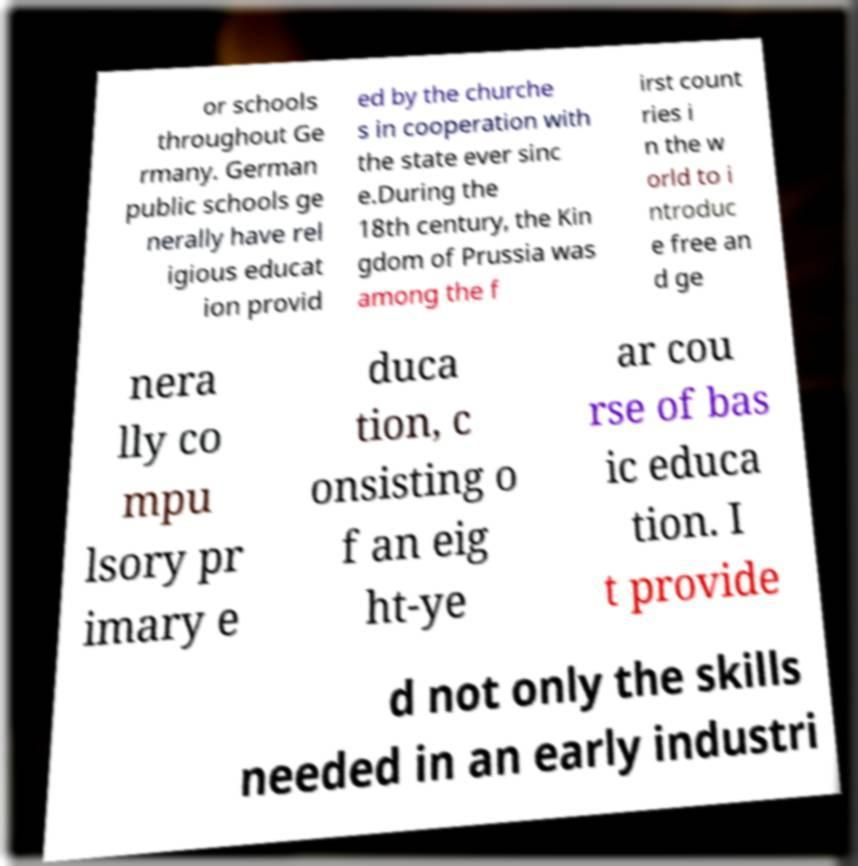Could you assist in decoding the text presented in this image and type it out clearly? or schools throughout Ge rmany. German public schools ge nerally have rel igious educat ion provid ed by the churche s in cooperation with the state ever sinc e.During the 18th century, the Kin gdom of Prussia was among the f irst count ries i n the w orld to i ntroduc e free an d ge nera lly co mpu lsory pr imary e duca tion, c onsisting o f an eig ht-ye ar cou rse of bas ic educa tion. I t provide d not only the skills needed in an early industri 